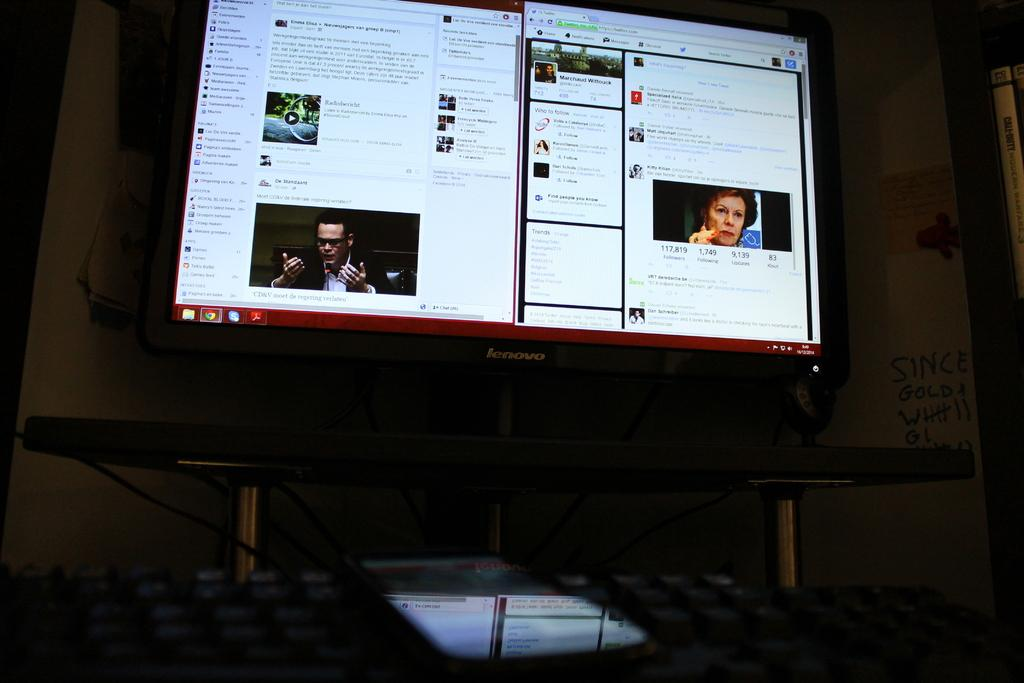<image>
Create a compact narrative representing the image presented. a computer monitor with words and pictures on it and one has 1749 following 